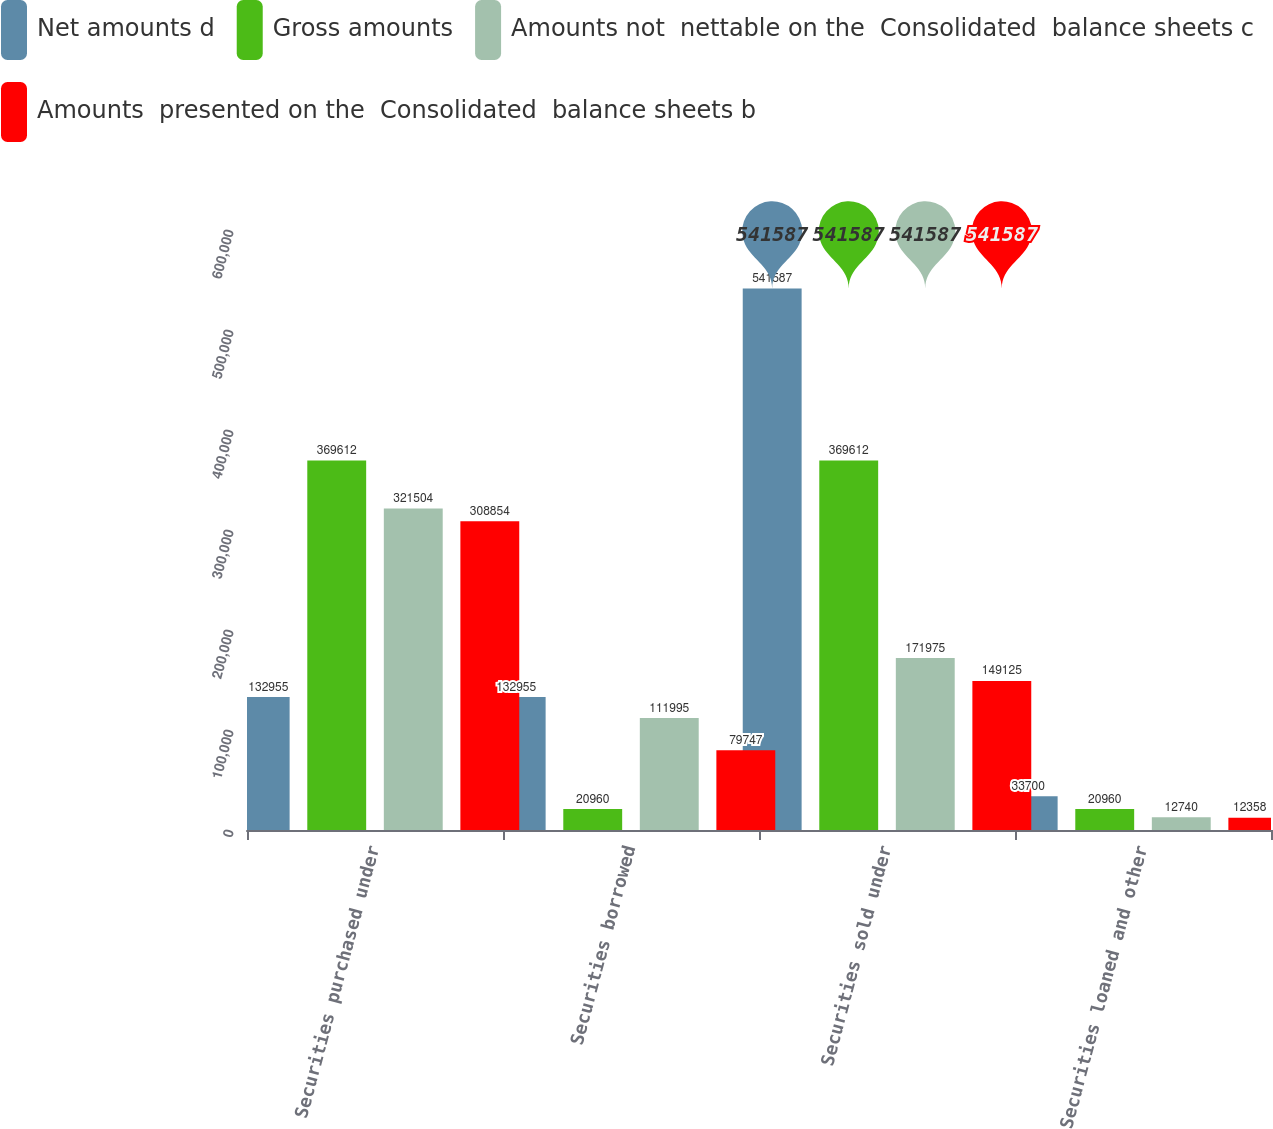Convert chart to OTSL. <chart><loc_0><loc_0><loc_500><loc_500><stacked_bar_chart><ecel><fcel>Securities purchased under<fcel>Securities borrowed<fcel>Securities sold under<fcel>Securities loaned and other<nl><fcel>Net amounts d<fcel>132955<fcel>132955<fcel>541587<fcel>33700<nl><fcel>Gross amounts<fcel>369612<fcel>20960<fcel>369612<fcel>20960<nl><fcel>Amounts not  nettable on the  Consolidated  balance sheets c<fcel>321504<fcel>111995<fcel>171975<fcel>12740<nl><fcel>Amounts  presented on the  Consolidated  balance sheets b<fcel>308854<fcel>79747<fcel>149125<fcel>12358<nl></chart> 